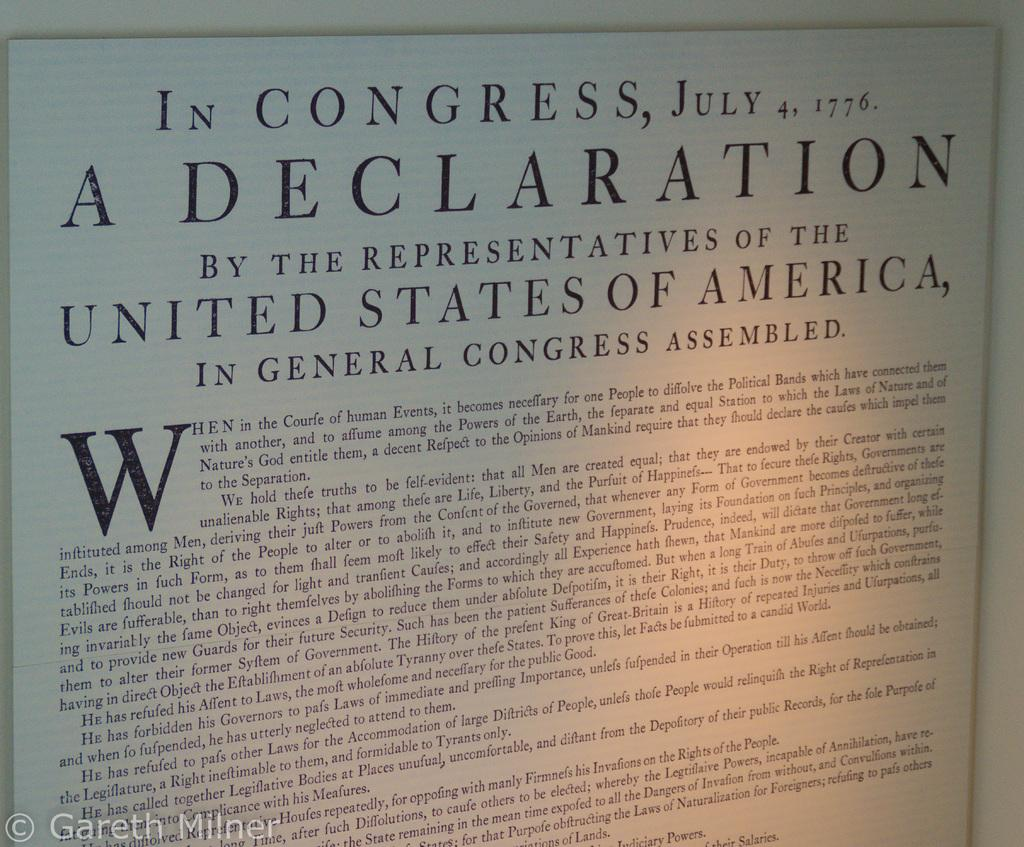Provide a one-sentence caption for the provided image. A copy of the declaration of independence from 1776. 